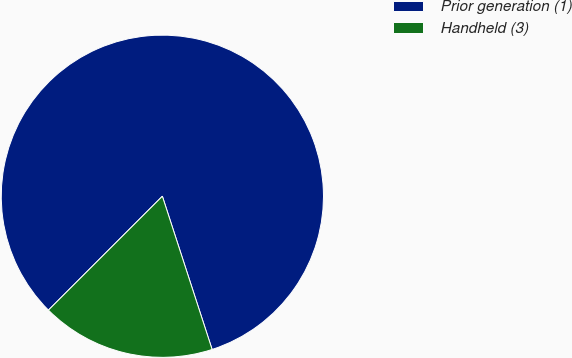<chart> <loc_0><loc_0><loc_500><loc_500><pie_chart><fcel>Prior generation (1)<fcel>Handheld (3)<nl><fcel>82.5%<fcel>17.5%<nl></chart> 